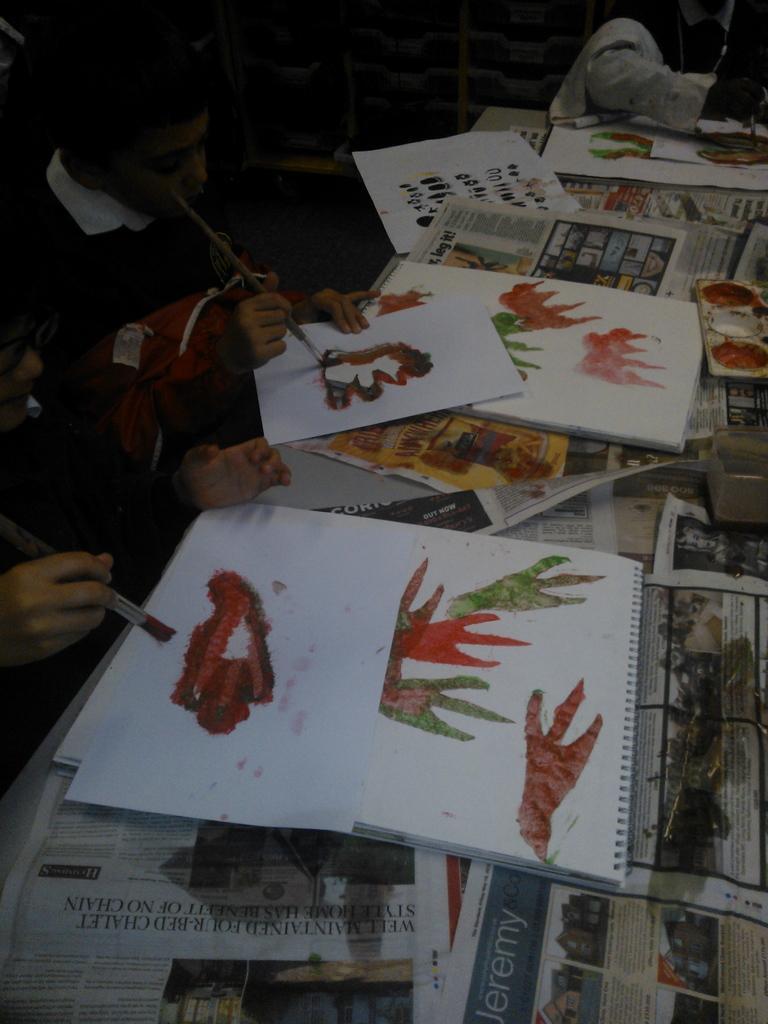Please provide a concise description of this image. In this image in the front there are papers with some text and drawing on it. On the left side there are persons drawing and in the background there are objects. 